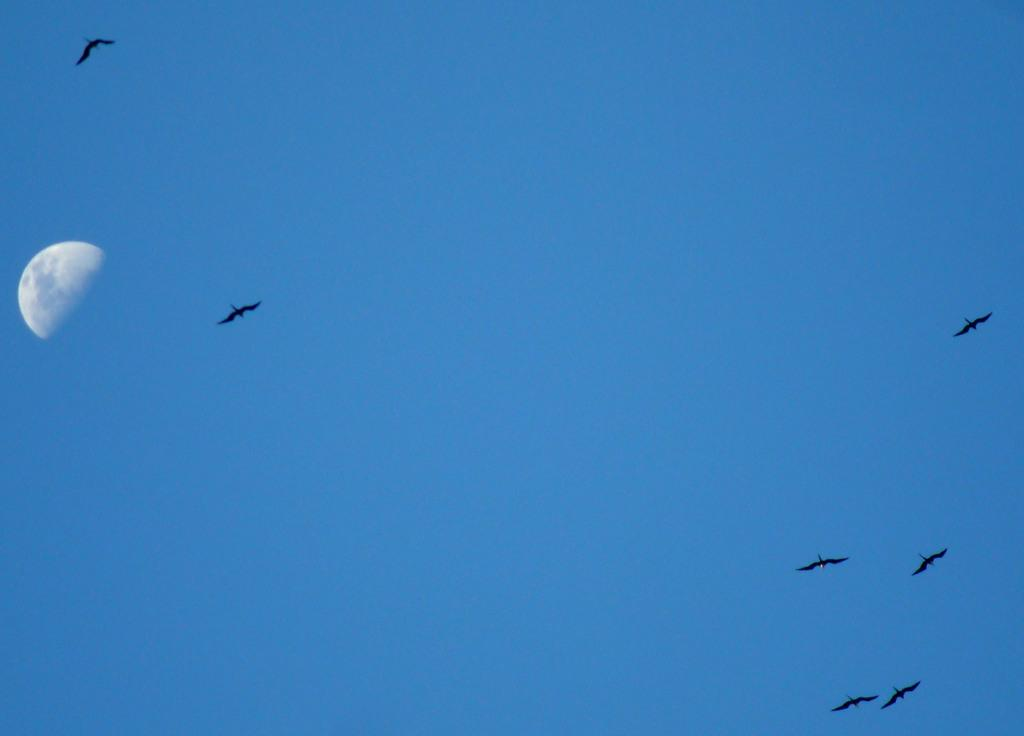What celestial object is located on the left side of the image? There is a moon on the left side of the image. What can be seen in the sky in the image? There are birds flying in the sky. What is the interest rate on the ghost in the image? There is no ghost present in the image, and therefore no interest rate can be determined. 